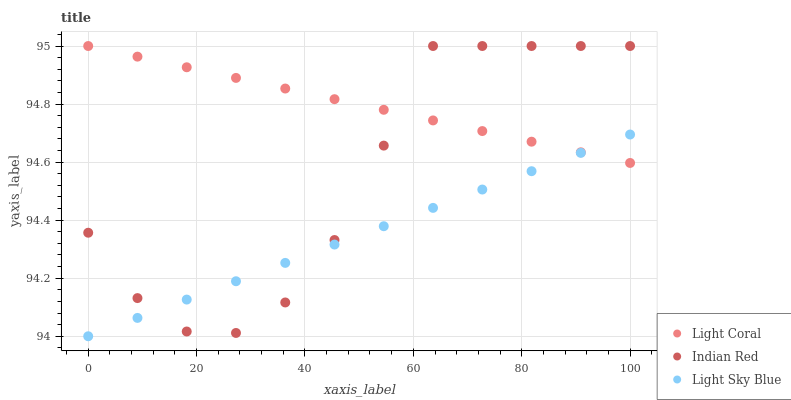Does Light Sky Blue have the minimum area under the curve?
Answer yes or no. Yes. Does Light Coral have the maximum area under the curve?
Answer yes or no. Yes. Does Indian Red have the minimum area under the curve?
Answer yes or no. No. Does Indian Red have the maximum area under the curve?
Answer yes or no. No. Is Light Sky Blue the smoothest?
Answer yes or no. Yes. Is Indian Red the roughest?
Answer yes or no. Yes. Is Indian Red the smoothest?
Answer yes or no. No. Is Light Sky Blue the roughest?
Answer yes or no. No. Does Light Sky Blue have the lowest value?
Answer yes or no. Yes. Does Indian Red have the lowest value?
Answer yes or no. No. Does Indian Red have the highest value?
Answer yes or no. Yes. Does Light Sky Blue have the highest value?
Answer yes or no. No. Does Light Sky Blue intersect Indian Red?
Answer yes or no. Yes. Is Light Sky Blue less than Indian Red?
Answer yes or no. No. Is Light Sky Blue greater than Indian Red?
Answer yes or no. No. 